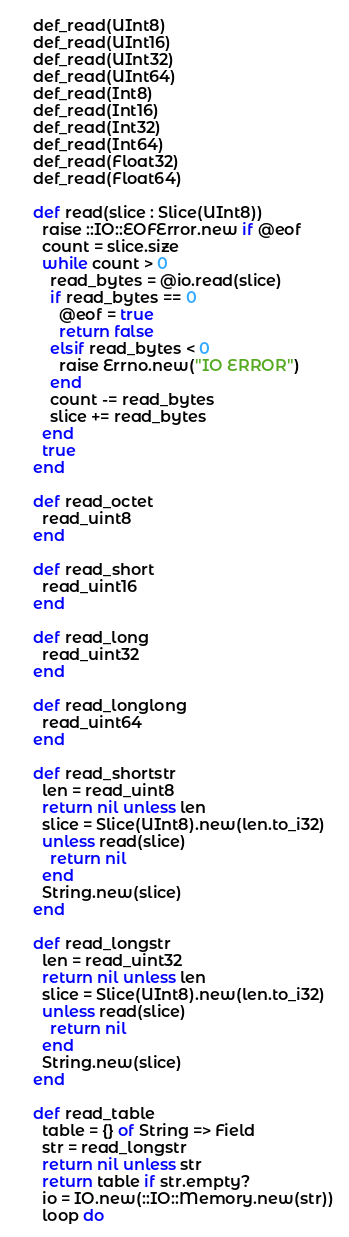Convert code to text. <code><loc_0><loc_0><loc_500><loc_500><_Crystal_>    def_read(UInt8)
    def_read(UInt16)
    def_read(UInt32)
    def_read(UInt64)
    def_read(Int8)
    def_read(Int16)
    def_read(Int32)
    def_read(Int64)
    def_read(Float32)
    def_read(Float64)

    def read(slice : Slice(UInt8))
      raise ::IO::EOFError.new if @eof
      count = slice.size
      while count > 0
        read_bytes = @io.read(slice)
        if read_bytes == 0
          @eof = true
          return false
        elsif read_bytes < 0
          raise Errno.new("IO ERROR")
        end
        count -= read_bytes
        slice += read_bytes
      end
      true
    end

    def read_octet
      read_uint8
    end

    def read_short
      read_uint16
    end

    def read_long
      read_uint32
    end

    def read_longlong
      read_uint64
    end

    def read_shortstr
      len = read_uint8
      return nil unless len
      slice = Slice(UInt8).new(len.to_i32)
      unless read(slice)
        return nil
      end
      String.new(slice)
    end

    def read_longstr
      len = read_uint32
      return nil unless len
      slice = Slice(UInt8).new(len.to_i32)
      unless read(slice)
        return nil
      end
      String.new(slice)
    end

    def read_table
      table = {} of String => Field
      str = read_longstr
      return nil unless str
      return table if str.empty?
      io = IO.new(::IO::Memory.new(str))
      loop do</code> 